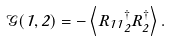<formula> <loc_0><loc_0><loc_500><loc_500>\mathcal { G } ( 1 , 2 ) = - \left < R _ { 1 } \Phi _ { 1 } \Phi _ { 2 } ^ { \dagger } R _ { 2 } ^ { \dagger } \right > .</formula> 